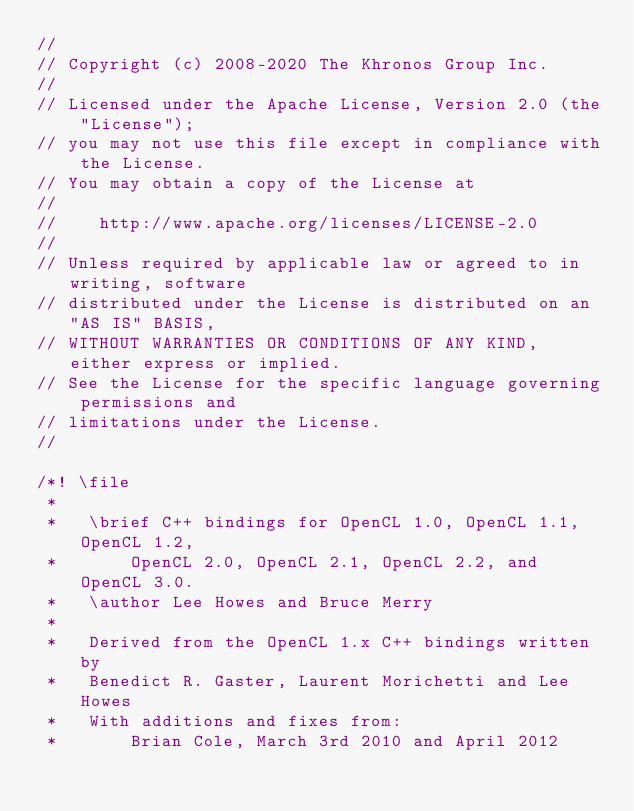Convert code to text. <code><loc_0><loc_0><loc_500><loc_500><_C++_>//
// Copyright (c) 2008-2020 The Khronos Group Inc.
//
// Licensed under the Apache License, Version 2.0 (the "License");
// you may not use this file except in compliance with the License.
// You may obtain a copy of the License at
//
//    http://www.apache.org/licenses/LICENSE-2.0
//
// Unless required by applicable law or agreed to in writing, software
// distributed under the License is distributed on an "AS IS" BASIS,
// WITHOUT WARRANTIES OR CONDITIONS OF ANY KIND, either express or implied.
// See the License for the specific language governing permissions and
// limitations under the License.
//

/*! \file
 *
 *   \brief C++ bindings for OpenCL 1.0, OpenCL 1.1, OpenCL 1.2,
 *       OpenCL 2.0, OpenCL 2.1, OpenCL 2.2, and OpenCL 3.0.
 *   \author Lee Howes and Bruce Merry
 *
 *   Derived from the OpenCL 1.x C++ bindings written by
 *   Benedict R. Gaster, Laurent Morichetti and Lee Howes
 *   With additions and fixes from:
 *       Brian Cole, March 3rd 2010 and April 2012</code> 